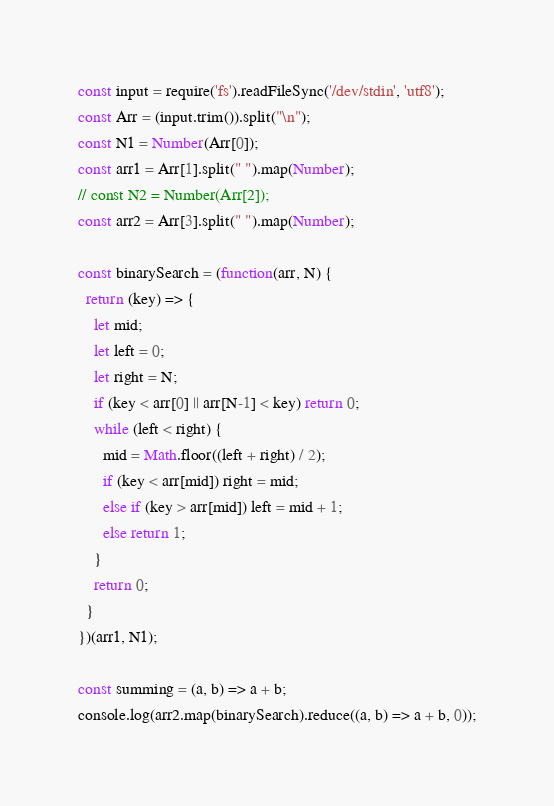<code> <loc_0><loc_0><loc_500><loc_500><_JavaScript_>const input = require('fs').readFileSync('/dev/stdin', 'utf8');
const Arr = (input.trim()).split("\n");
const N1 = Number(Arr[0]);
const arr1 = Arr[1].split(" ").map(Number);
// const N2 = Number(Arr[2]);
const arr2 = Arr[3].split(" ").map(Number);

const binarySearch = (function(arr, N) {
  return (key) => {   
    let mid;
    let left = 0;
    let right = N;
    if (key < arr[0] || arr[N-1] < key) return 0;
    while (left < right) {
      mid = Math.floor((left + right) / 2);
      if (key < arr[mid]) right = mid;
      else if (key > arr[mid]) left = mid + 1;
      else return 1;
    }
    return 0;
  }
})(arr1, N1);

const summing = (a, b) => a + b;
console.log(arr2.map(binarySearch).reduce((a, b) => a + b, 0));
</code> 